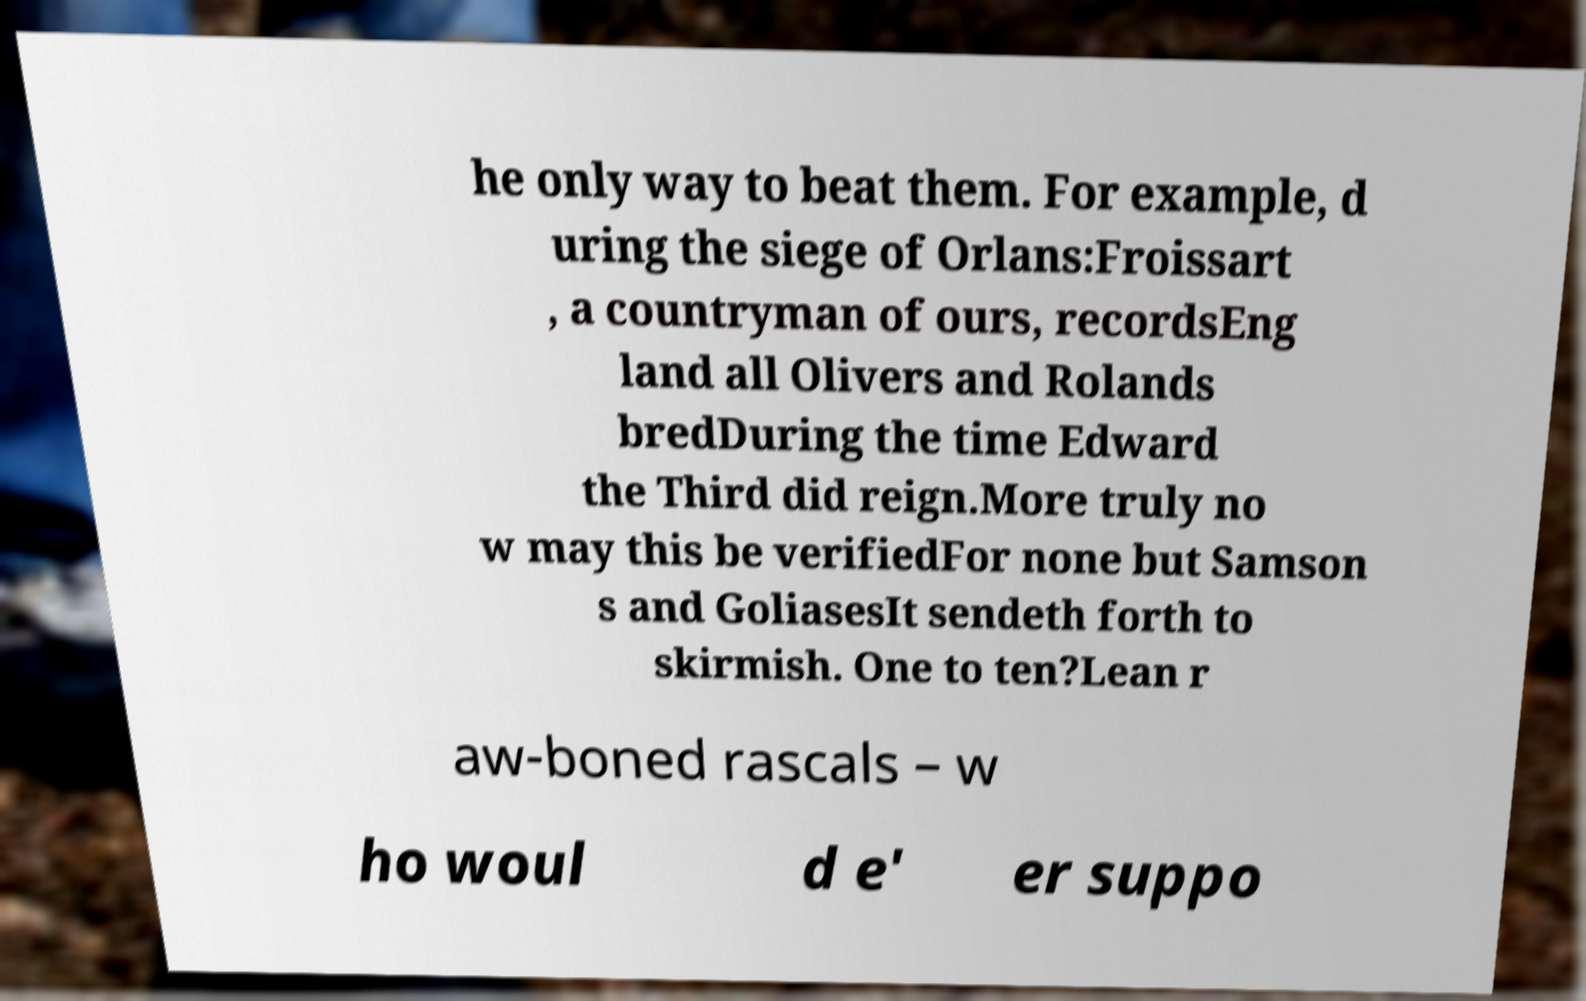Please identify and transcribe the text found in this image. he only way to beat them. For example, d uring the siege of Orlans:Froissart , a countryman of ours, recordsEng land all Olivers and Rolands bredDuring the time Edward the Third did reign.More truly no w may this be verifiedFor none but Samson s and GoliasesIt sendeth forth to skirmish. One to ten?Lean r aw-boned rascals – w ho woul d e' er suppo 